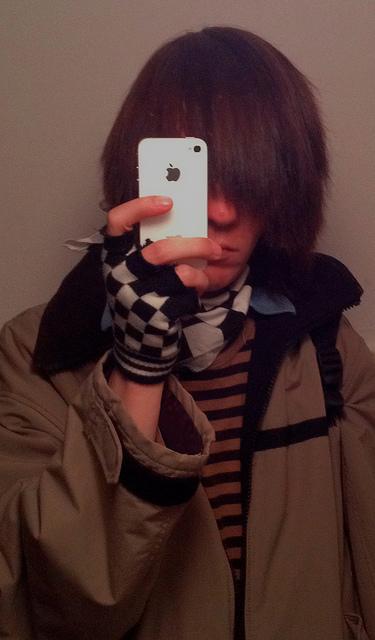What facial feature is this person hiding?
Short answer required. Eyes. What pattern is on the gloves?
Keep it brief. Checkered. What brand of phone is this?
Give a very brief answer. Apple. 